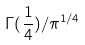Convert formula to latex. <formula><loc_0><loc_0><loc_500><loc_500>\Gamma ( \frac { 1 } { 4 } ) / \pi ^ { 1 / 4 }</formula> 